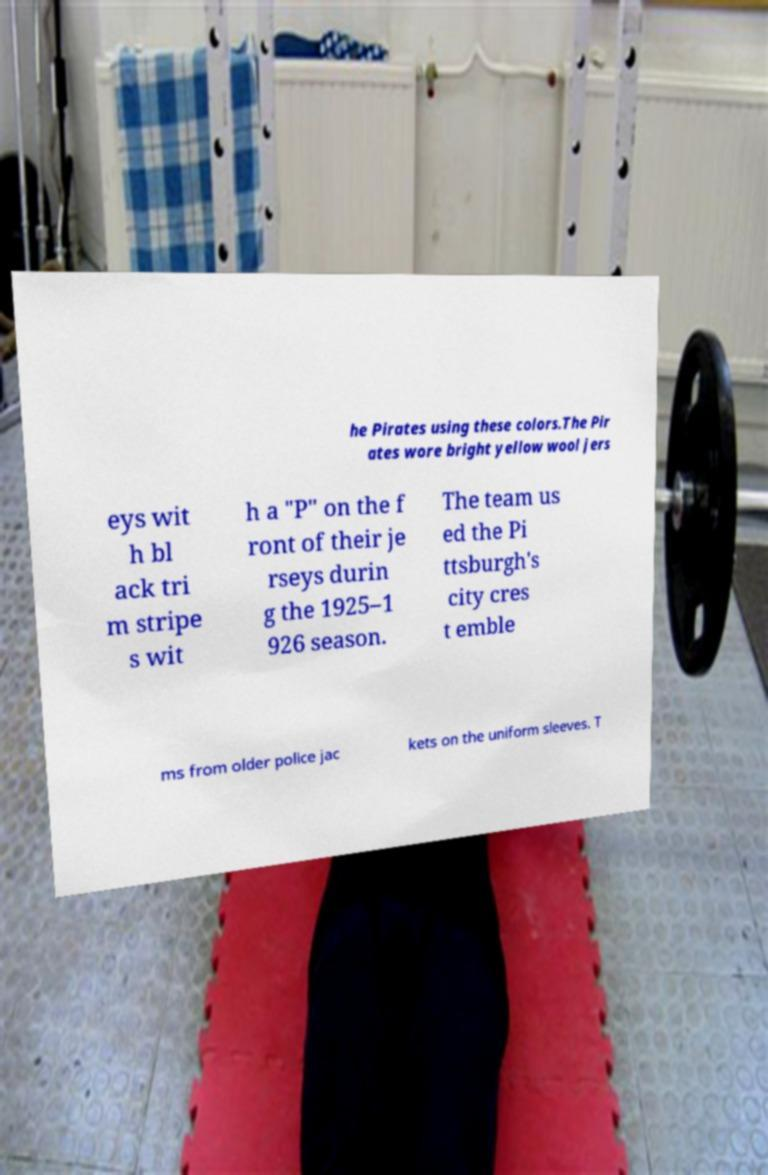There's text embedded in this image that I need extracted. Can you transcribe it verbatim? he Pirates using these colors.The Pir ates wore bright yellow wool jers eys wit h bl ack tri m stripe s wit h a "P" on the f ront of their je rseys durin g the 1925–1 926 season. The team us ed the Pi ttsburgh's city cres t emble ms from older police jac kets on the uniform sleeves. T 